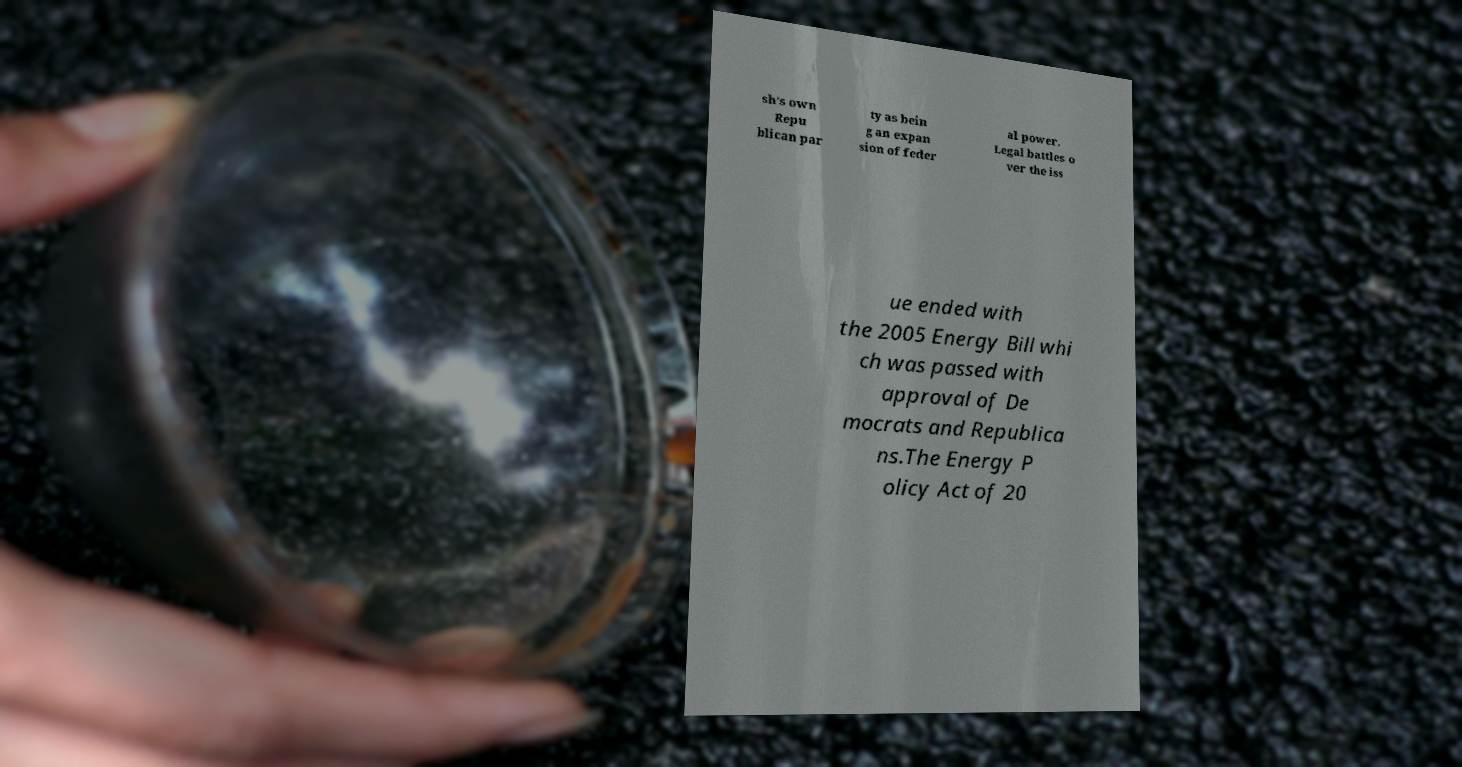Can you accurately transcribe the text from the provided image for me? sh’s own Repu blican par ty as bein g an expan sion of feder al power. Legal battles o ver the iss ue ended with the 2005 Energy Bill whi ch was passed with approval of De mocrats and Republica ns.The Energy P olicy Act of 20 